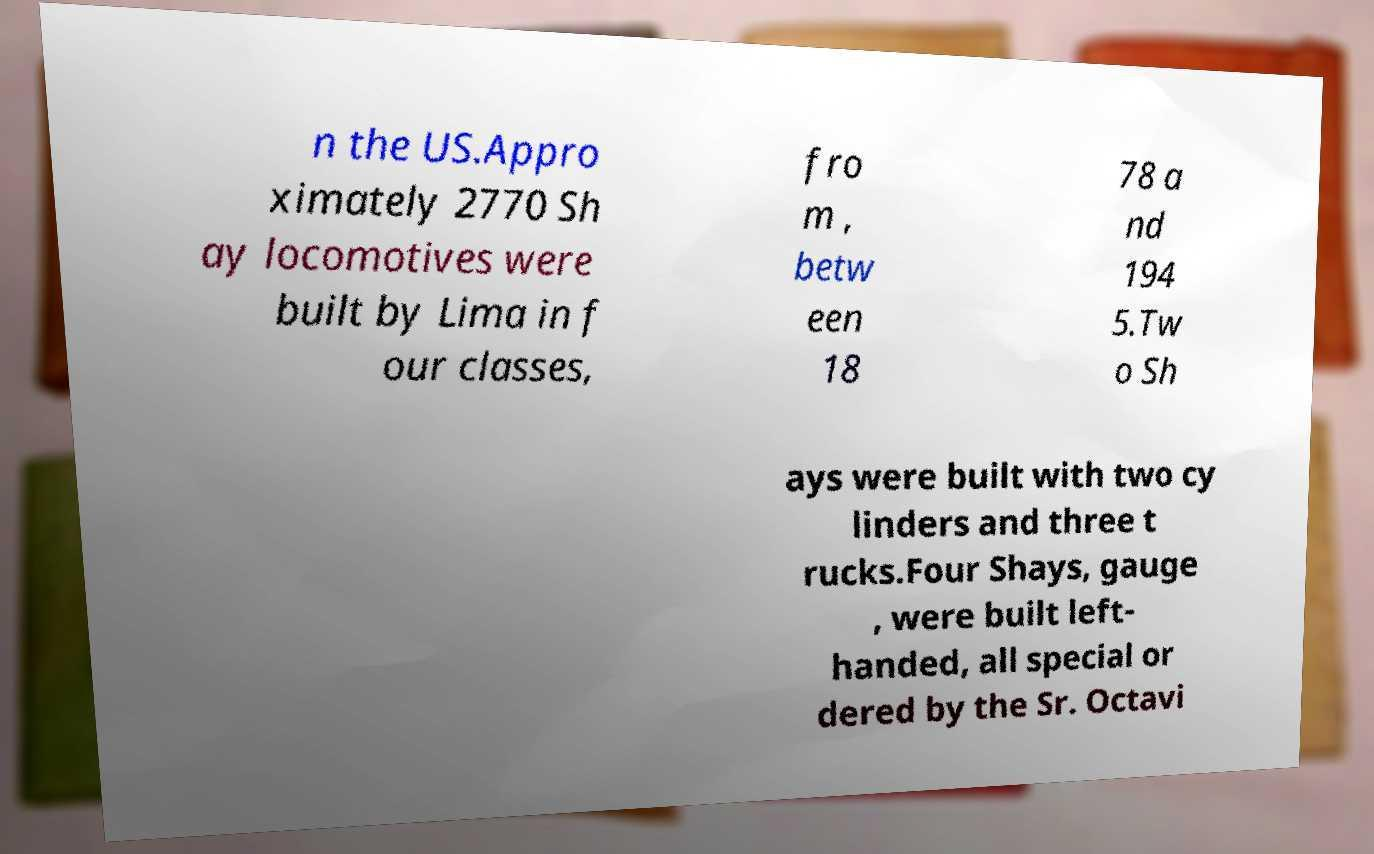Can you read and provide the text displayed in the image?This photo seems to have some interesting text. Can you extract and type it out for me? n the US.Appro ximately 2770 Sh ay locomotives were built by Lima in f our classes, fro m , betw een 18 78 a nd 194 5.Tw o Sh ays were built with two cy linders and three t rucks.Four Shays, gauge , were built left- handed, all special or dered by the Sr. Octavi 